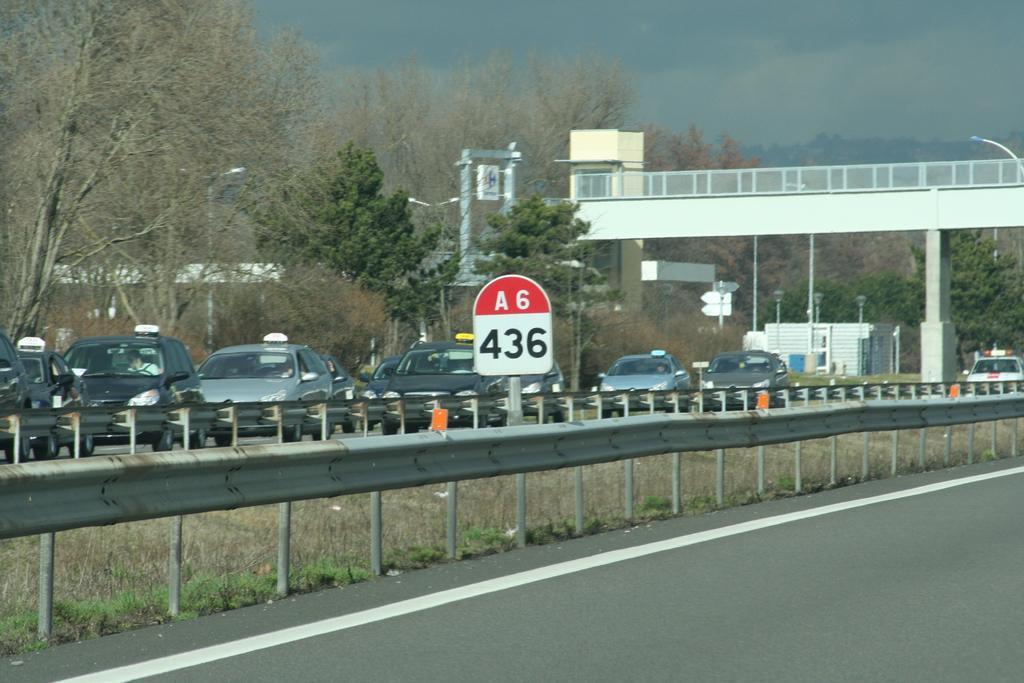Describe this image in one or two sentences. This image is clicked on the road. There are cars moving on the road. In the center there is a railing. To the right there is a road. There is a bridge on the road. Beside the road there are street light poles. In the background there are trees and a building. At the top there is the sky. 